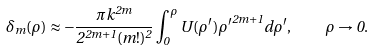<formula> <loc_0><loc_0><loc_500><loc_500>\delta _ { m } ( \rho ) \approx - \frac { \pi k ^ { 2 m } } { 2 ^ { 2 m + 1 } ( m ! ) ^ { 2 } } \int _ { 0 } ^ { \rho } U ( \rho ^ { \prime } ) { \rho ^ { \prime } } ^ { 2 m + 1 } d \rho ^ { \prime } , \quad \rho \rightarrow 0 .</formula> 